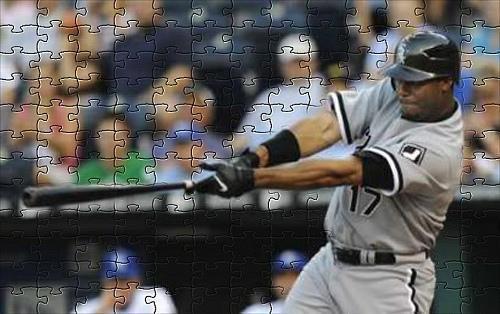How many baseball bats are in the photo?
Give a very brief answer. 1. How many people are visible?
Give a very brief answer. 5. How many people are on a motorcycle in the image?
Give a very brief answer. 0. 